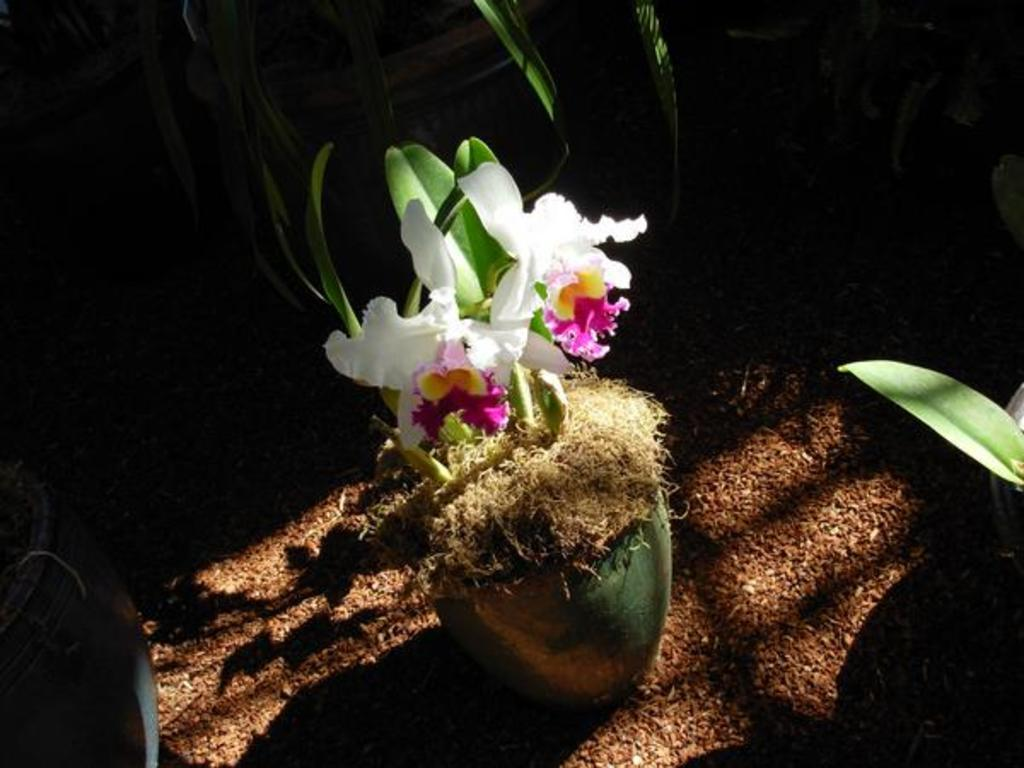What type of plant is in the pot in the image? There is a plant with flowers in a pot in the image. Where is the pot with the plant located? The pot is placed on the ground. Are there any other plants visible in the image? Yes, there are other plants in pots around the main plant. What type of leather is used to make the middle part of the plant in the image? There is no leather present in the image, as it features plants in pots. 